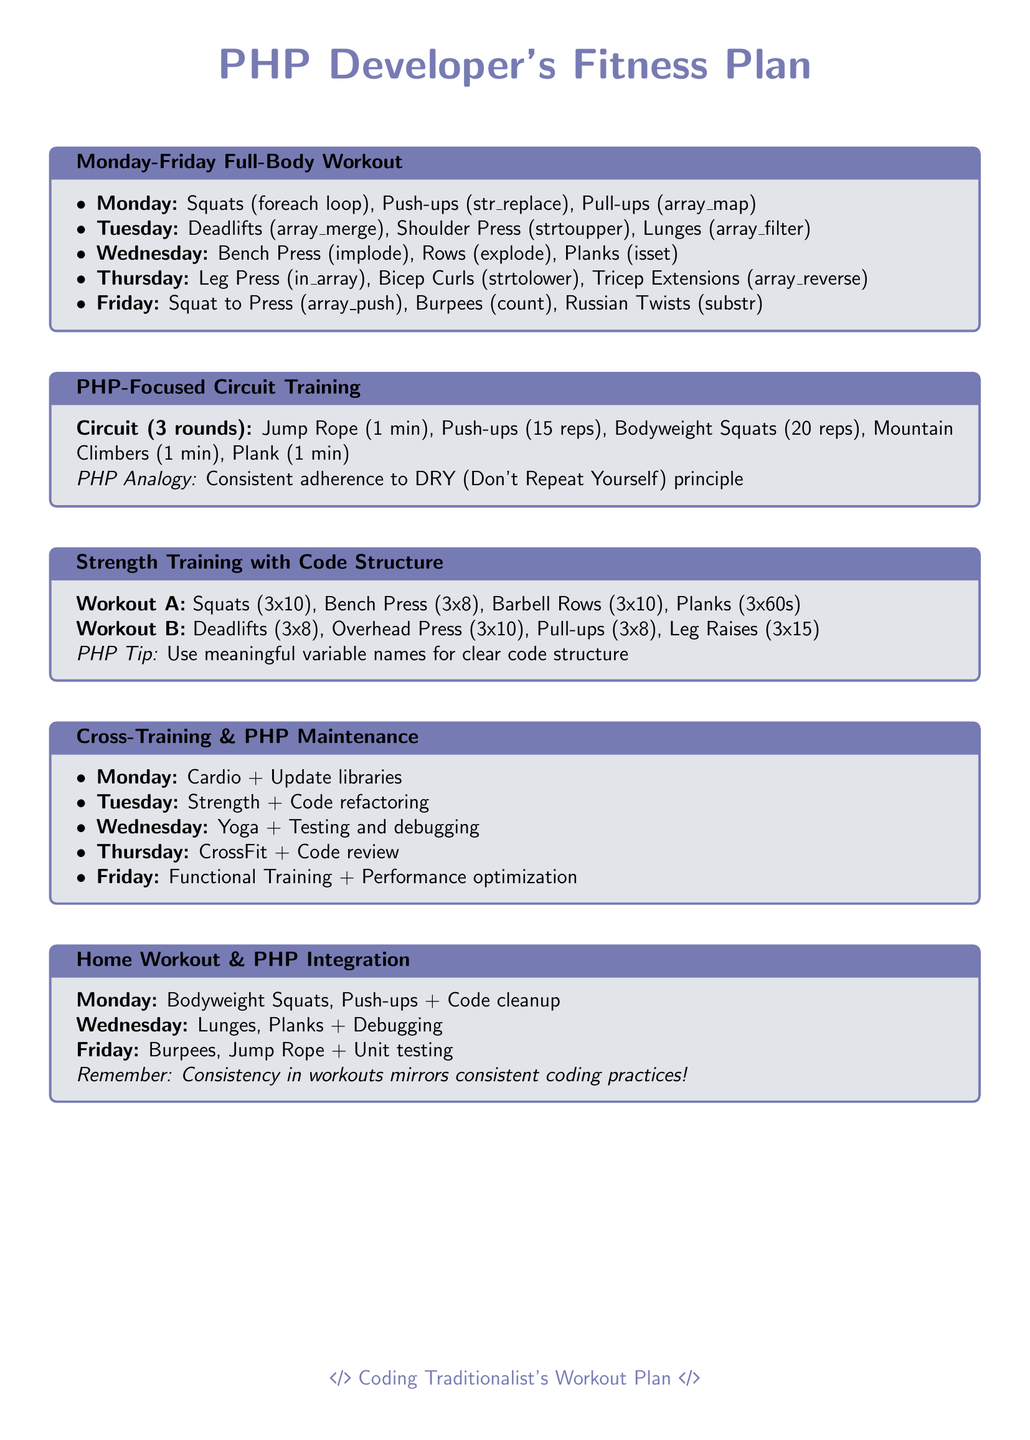What is the title of the document? The title is found at the top of the document, which states "PHP Developer's Fitness Plan."
Answer: PHP Developer's Fitness Plan What is the focus of the workout routine on Monday? The Monday workout includes exercises such as Squats, Push-ups, and Pull-ups, which are listed under that day's section.
Answer: Squats, Push-ups, Pull-ups How many exercises are included in the PHP-Focused Circuit Training? The circuit consists of five different exercises listed in the document under that section.
Answer: Five What is the PHP analogy related to circuit training? The analogy emphasizes the importance of not repeating oneself in code, mirroring the approach to circuit training.
Answer: DRY (Don't Repeat Yourself) What does the Strength Training section suggest about code structure? The document provides a tip about maintaining meaningful variable names, emphasizing their importance for clear code structure.
Answer: Meaningful variable names How many rounds are suggested for the circuit training? The circuit training routine mentions doing the circuit for three rounds.
Answer: Three rounds What type of workout is suggested for Wednesday in the Cross-Training section? The document states that Wednesday includes Yoga and emphasizes testing and debugging as its PHP maintenance activity.
Answer: Yoga What equipment is required for the Home Workout plan? The home workout is designed to be executed with minimal equipment, as clarified in the section title.
Answer: Minimal equipment What is the suggested exercise for Friday's Home Workout? The Friday routine includes Burpees and Jump Rope, along with a coding task.
Answer: Burpees, Jump Rope 